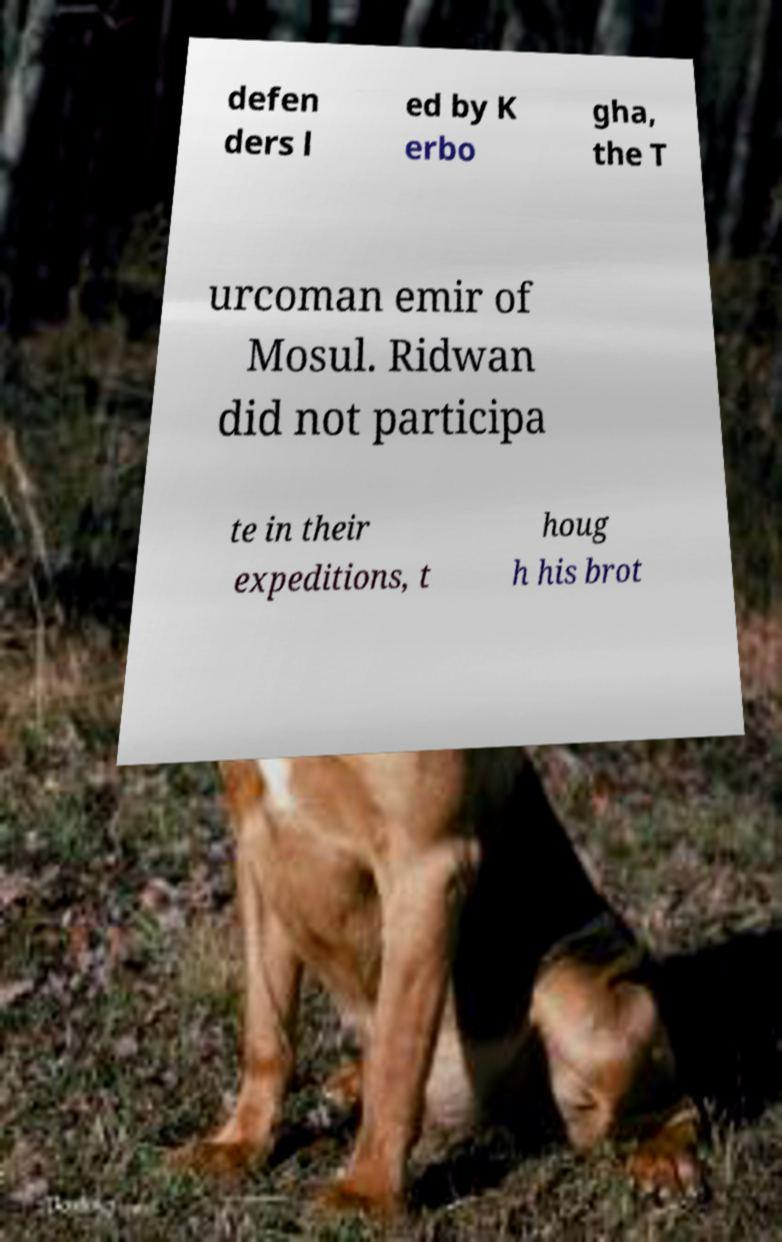Could you assist in decoding the text presented in this image and type it out clearly? defen ders l ed by K erbo gha, the T urcoman emir of Mosul. Ridwan did not participa te in their expeditions, t houg h his brot 